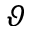Convert formula to latex. <formula><loc_0><loc_0><loc_500><loc_500>\vartheta</formula> 